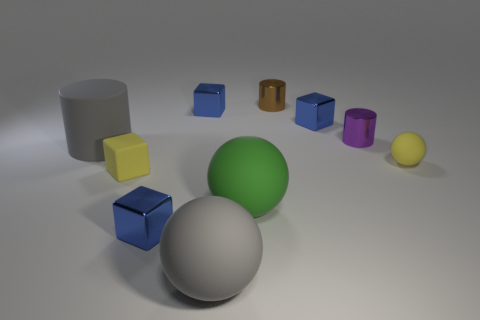Subtract all small purple cylinders. How many cylinders are left? 2 Subtract all brown cylinders. How many cylinders are left? 2 Subtract all spheres. How many objects are left? 7 Add 8 big matte cylinders. How many big matte cylinders are left? 9 Add 4 big blue rubber cylinders. How many big blue rubber cylinders exist? 4 Subtract 0 green cubes. How many objects are left? 10 Subtract 2 balls. How many balls are left? 1 Subtract all purple balls. Subtract all purple cylinders. How many balls are left? 3 Subtract all yellow blocks. How many red spheres are left? 0 Subtract all tiny blue objects. Subtract all purple things. How many objects are left? 6 